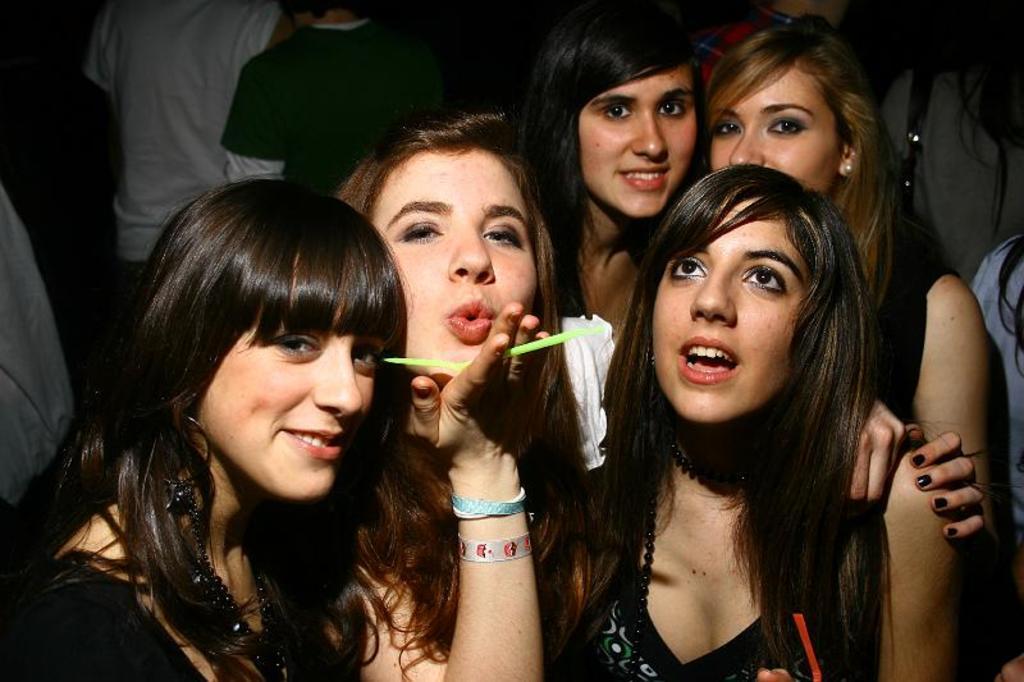Could you give a brief overview of what you see in this image? In the middle of the picture we can see five women. In the background we can see few persons. 